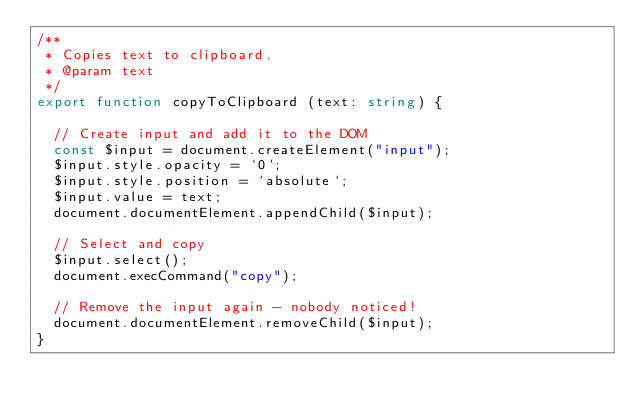<code> <loc_0><loc_0><loc_500><loc_500><_TypeScript_>/**
 * Copies text to clipboard.
 * @param text
 */
export function copyToClipboard (text: string) {

	// Create input and add it to the DOM
	const $input = document.createElement("input");
	$input.style.opacity = `0`;
	$input.style.position = `absolute`;
	$input.value = text;
	document.documentElement.appendChild($input);

	// Select and copy
	$input.select();
	document.execCommand("copy");

	// Remove the input again - nobody noticed!
	document.documentElement.removeChild($input);
}
</code> 